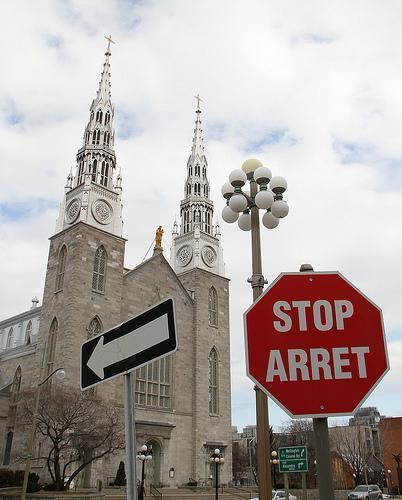How many signs are shown?
Give a very brief answer. 4. How many crosses are in the photo?
Give a very brief answer. 2. 